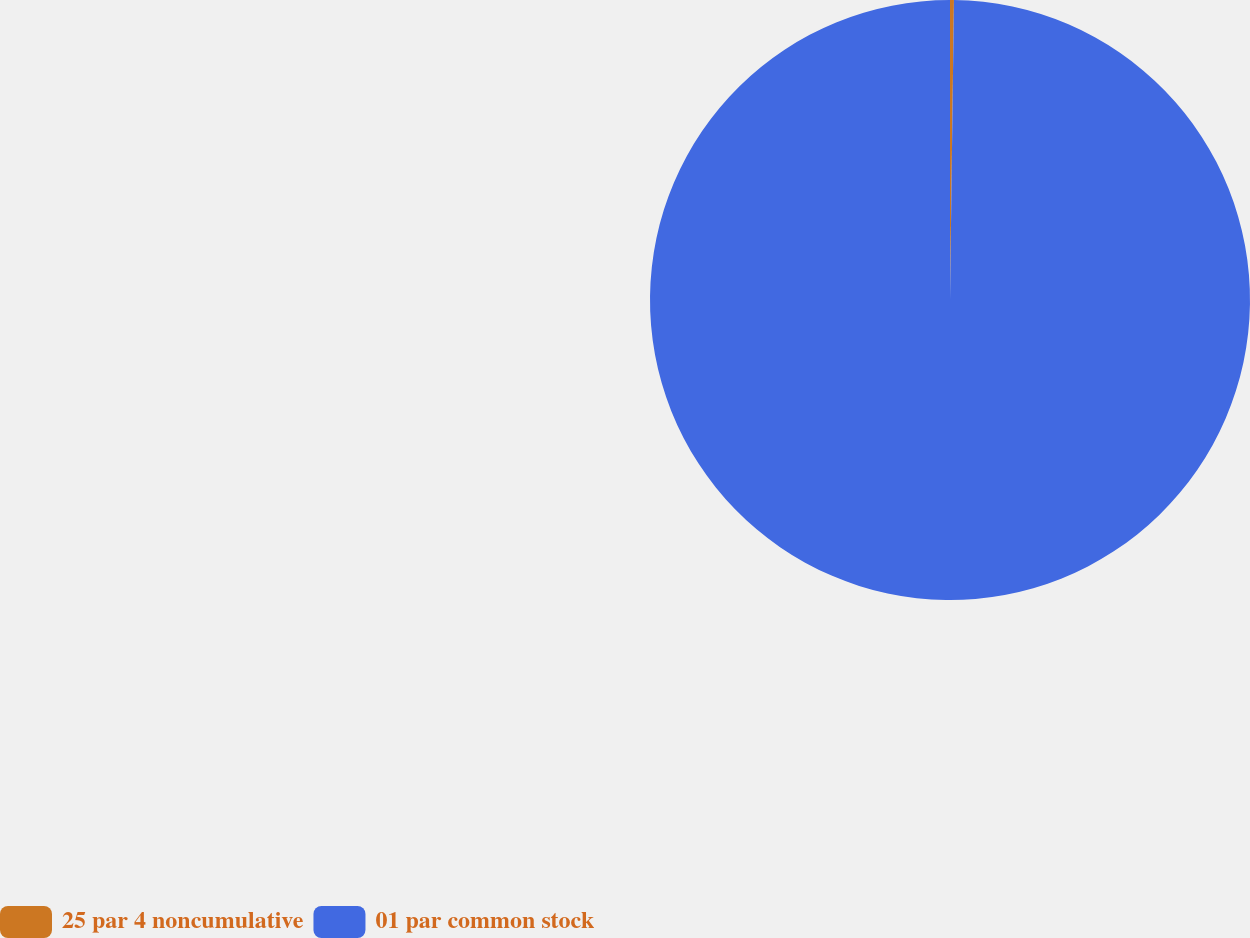Convert chart. <chart><loc_0><loc_0><loc_500><loc_500><pie_chart><fcel>25 par 4 noncumulative<fcel>01 par common stock<nl><fcel>0.21%<fcel>99.79%<nl></chart> 